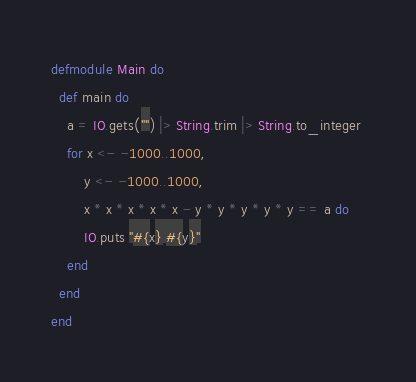<code> <loc_0><loc_0><loc_500><loc_500><_Elixir_>defmodule Main do
  def main do
  	a = IO.gets("") |> String.trim |> String.to_integer
    for x <- -1000..1000,
    	y <- -1000..1000,
    	x * x * x * x * x - y * y * y * y * y == a do	
    	IO.puts "#{x} #{y}"
	end
  end
end
</code> 